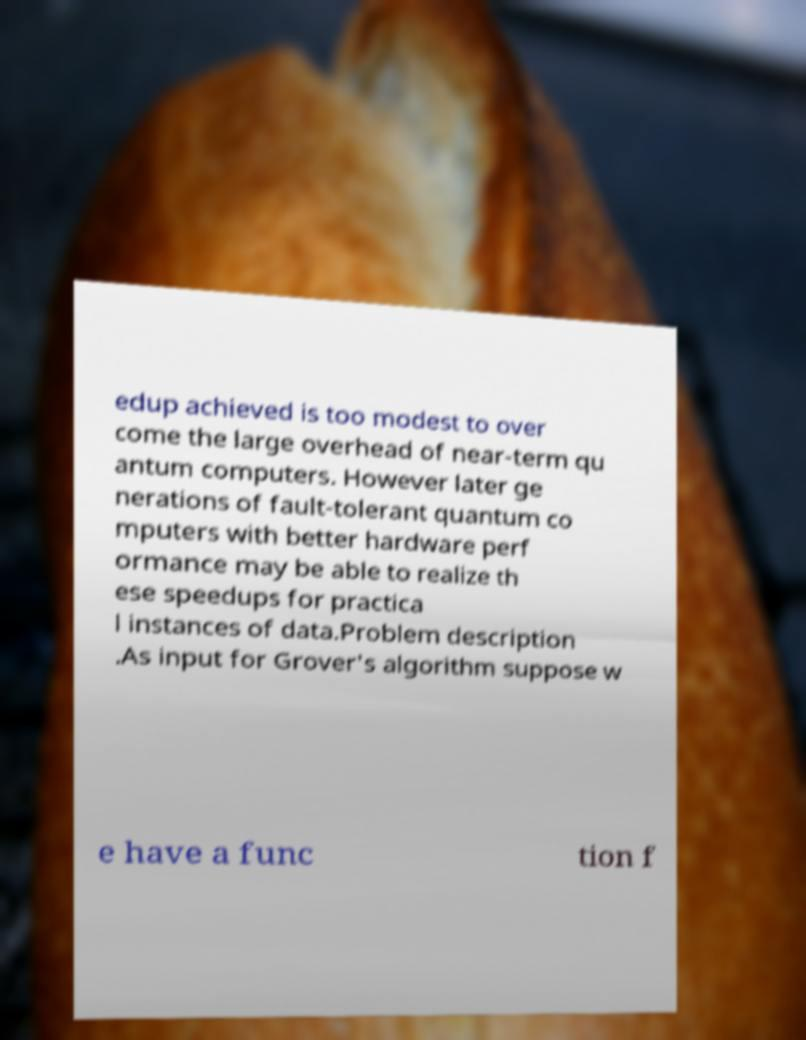Could you extract and type out the text from this image? edup achieved is too modest to over come the large overhead of near-term qu antum computers. However later ge nerations of fault-tolerant quantum co mputers with better hardware perf ormance may be able to realize th ese speedups for practica l instances of data.Problem description .As input for Grover's algorithm suppose w e have a func tion f 